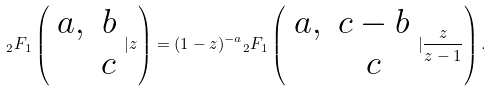<formula> <loc_0><loc_0><loc_500><loc_500>{ _ { 2 } F _ { 1 } } \left ( \begin{array} { c c } a , & b \\ & c \end{array} | z \right ) = ( 1 - z ) ^ { - a } { _ { 2 } F _ { 1 } } \left ( \begin{array} { c c } a , & c - b \\ & c \end{array} | \frac { z } { z - 1 } \right ) .</formula> 